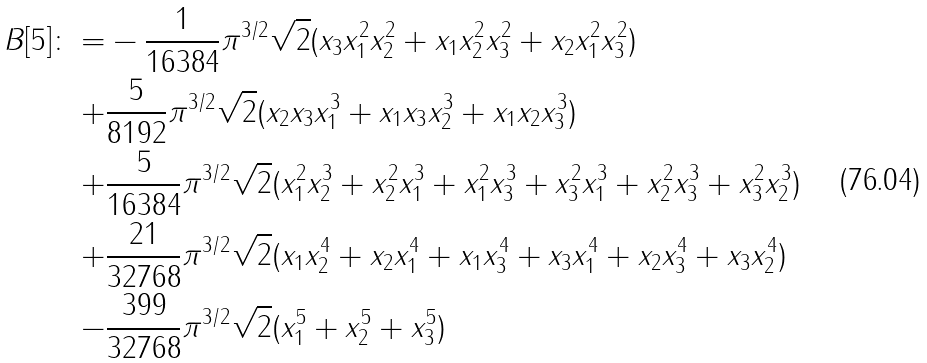Convert formula to latex. <formula><loc_0><loc_0><loc_500><loc_500>B [ 5 ] \colon = & - \frac { 1 } { 1 6 3 8 4 } \pi ^ { 3 / 2 } \sqrt { 2 } ( x _ { 3 } x _ { 1 } ^ { 2 } x _ { 2 } ^ { 2 } + x _ { 1 } x _ { 2 } ^ { 2 } x _ { 3 } ^ { 2 } + x _ { 2 } x _ { 1 } ^ { 2 } x _ { 3 } ^ { 2 } ) \\ + & \frac { 5 } { 8 1 9 2 } \pi ^ { 3 / 2 } \sqrt { 2 } ( x _ { 2 } x _ { 3 } x _ { 1 } ^ { 3 } + x _ { 1 } x _ { 3 } x _ { 2 } ^ { 3 } + x _ { 1 } x _ { 2 } x _ { 3 } ^ { 3 } ) \\ + & \frac { 5 } { 1 6 3 8 4 } \pi ^ { 3 / 2 } \sqrt { 2 } ( x _ { 1 } ^ { 2 } x _ { 2 } ^ { 3 } + x _ { 2 } ^ { 2 } x _ { 1 } ^ { 3 } + x _ { 1 } ^ { 2 } x _ { 3 } ^ { 3 } + x _ { 3 } ^ { 2 } x _ { 1 } ^ { 3 } + x _ { 2 } ^ { 2 } x _ { 3 } ^ { 3 } + x _ { 3 } ^ { 2 } x _ { 2 } ^ { 3 } ) \\ + & \frac { 2 1 } { 3 2 7 6 8 } \pi ^ { 3 / 2 } \sqrt { 2 } ( x _ { 1 } x _ { 2 } ^ { 4 } + x _ { 2 } x _ { 1 } ^ { 4 } + x _ { 1 } x _ { 3 } ^ { 4 } + x _ { 3 } x _ { 1 } ^ { 4 } + x _ { 2 } x _ { 3 } ^ { 4 } + x _ { 3 } x _ { 2 } ^ { 4 } ) \\ - & \frac { 3 9 9 } { 3 2 7 6 8 } \pi ^ { 3 / 2 } \sqrt { 2 } ( x _ { 1 } ^ { 5 } + x _ { 2 } ^ { 5 } + x _ { 3 } ^ { 5 } )</formula> 